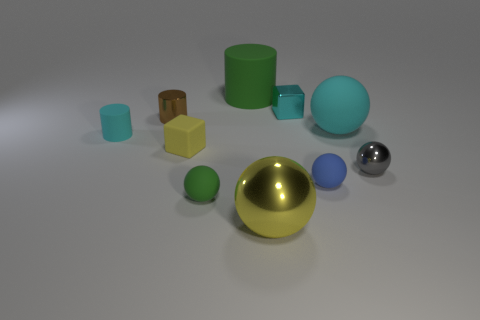Do the large metal thing and the small rubber block have the same color?
Your response must be concise. Yes. There is a large matte object to the left of the big yellow shiny thing; what color is it?
Give a very brief answer. Green. There is a tiny cylinder that is the same color as the metallic cube; what material is it?
Keep it short and to the point. Rubber. How many rubber things are the same color as the shiny block?
Offer a terse response. 2. There is a blue ball; is its size the same as the block that is on the left side of the big green rubber thing?
Your answer should be compact. Yes. There is a gray object that is right of the rubber ball to the left of the green matte object that is behind the tiny gray ball; what size is it?
Your response must be concise. Small. There is a small blue matte thing; what number of cyan things are on the right side of it?
Your answer should be compact. 1. What is the yellow object in front of the tiny blue sphere that is in front of the tiny cyan rubber object made of?
Keep it short and to the point. Metal. Is the brown thing the same size as the yellow matte block?
Provide a succinct answer. Yes. What number of objects are large objects that are to the right of the large matte cylinder or tiny cyan things that are behind the tiny cyan rubber object?
Provide a short and direct response. 3. 